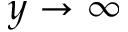Convert formula to latex. <formula><loc_0><loc_0><loc_500><loc_500>y \rightarrow \infty</formula> 